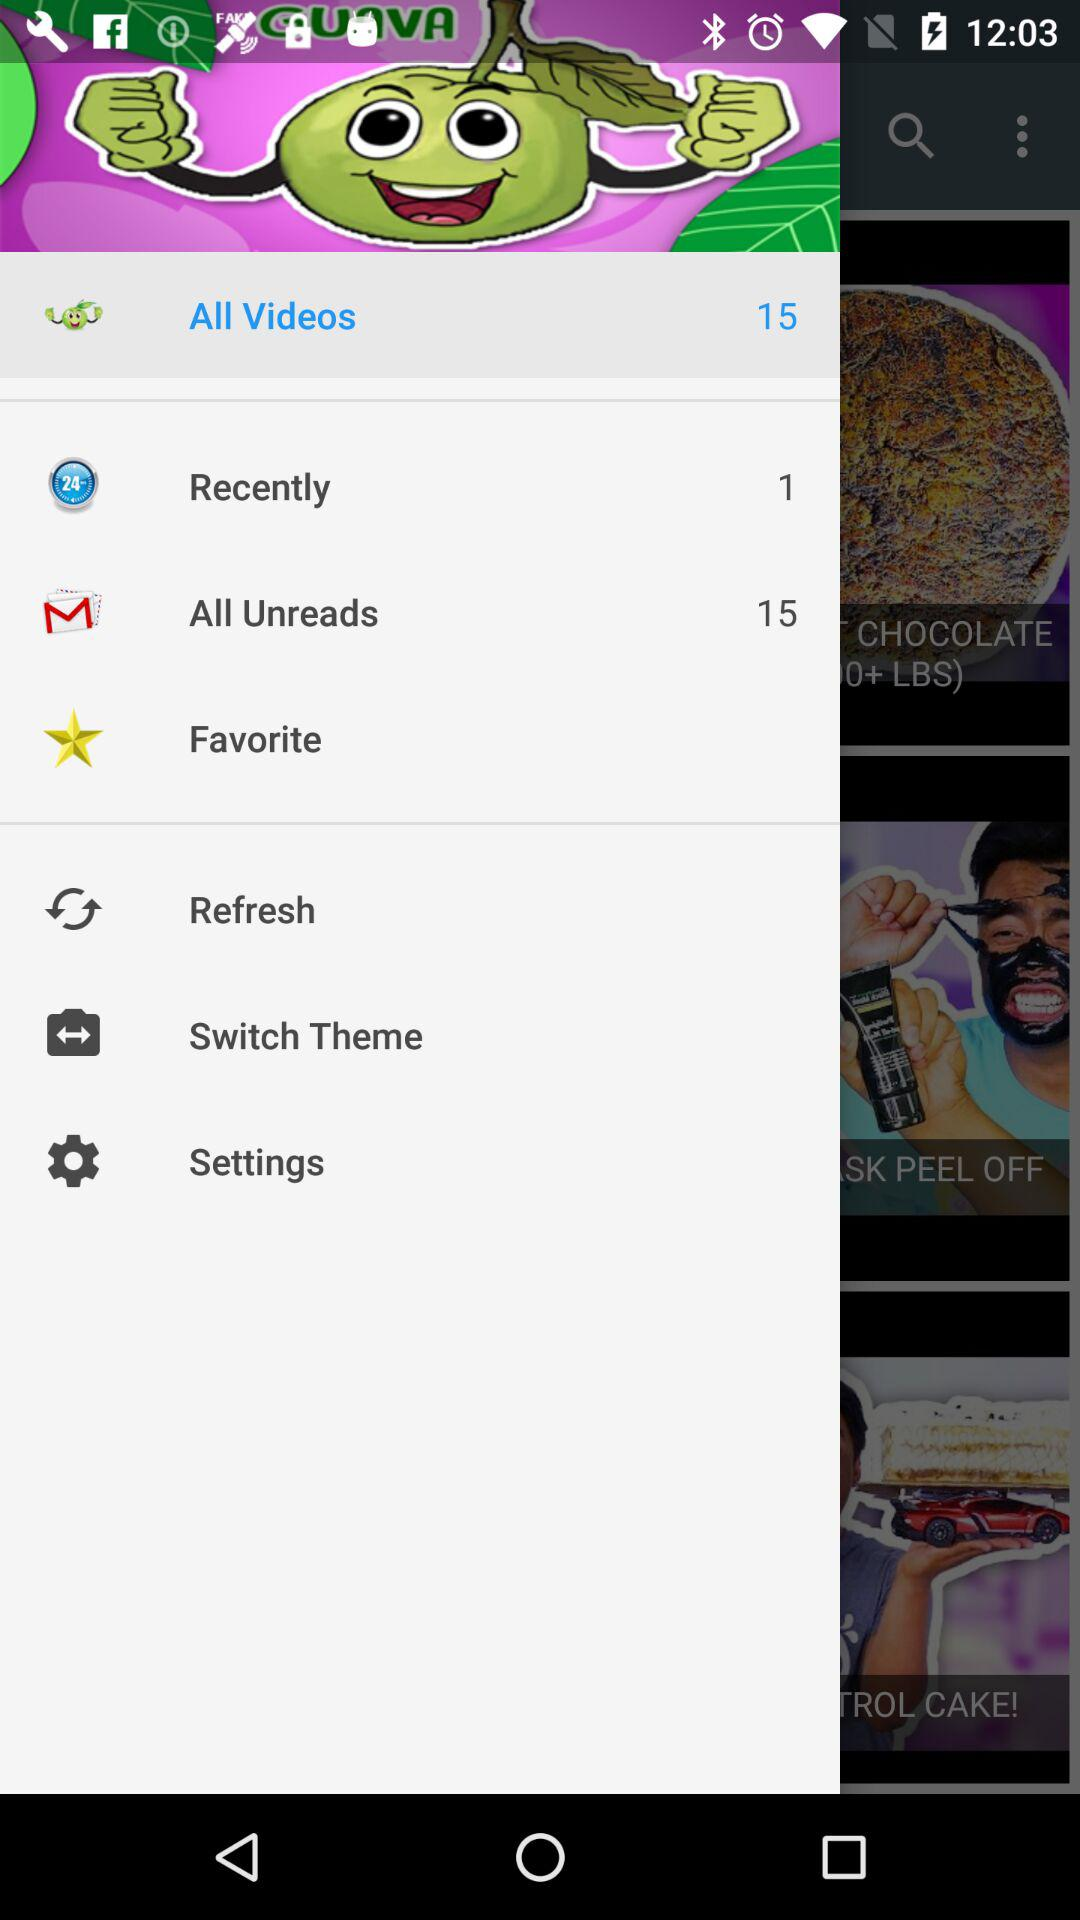What's the total count of videos? The total count of videos is 15. 